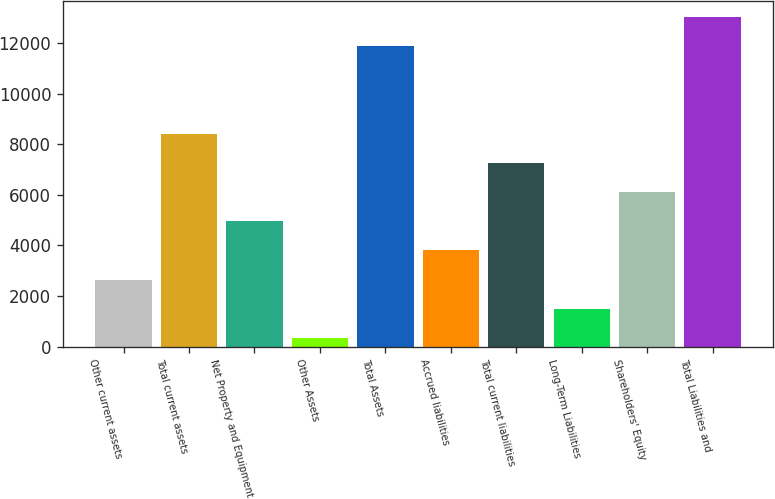Convert chart. <chart><loc_0><loc_0><loc_500><loc_500><bar_chart><fcel>Other current assets<fcel>Total current assets<fcel>Net Property and Equipment<fcel>Other Assets<fcel>Total Assets<fcel>Accrued liabilities<fcel>Total current liabilities<fcel>Long-Term Liabilities<fcel>Shareholders' Equity<fcel>Total Liabilities and<nl><fcel>2651.2<fcel>8409.2<fcel>4954.4<fcel>348<fcel>11864<fcel>3802.8<fcel>7257.6<fcel>1499.6<fcel>6106<fcel>13015.6<nl></chart> 